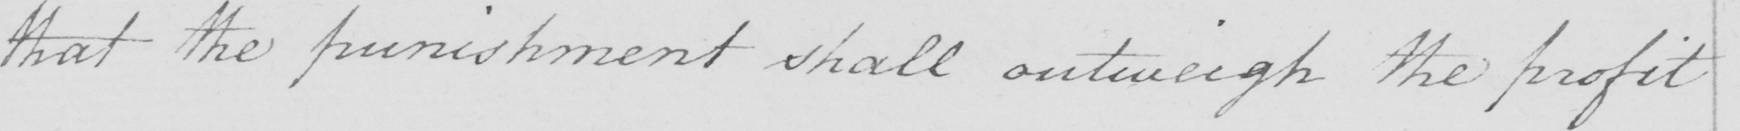What text is written in this handwritten line? that the punishment shall outweigh the profit 